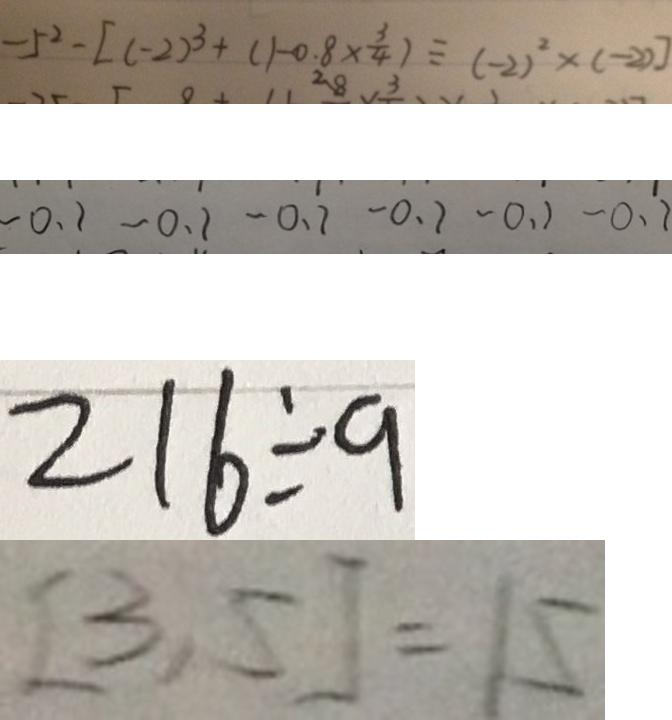<formula> <loc_0><loc_0><loc_500><loc_500>- 5 ^ { 2 } - [ ( - 2 ) ^ { 3 } + ( 1 + 0 . 8 \times \frac { 3 } { 4 } ) \div ( - 2 ) ^ { 2 } \times ( - 2 ) ] 
 - 0 . 1 - 0 . 1 - 0 . 1 - 0 . 1 - 0 . 1 - 0 . 1 
 2 1 6 \div a 
 [ 3 , 5 ] = 1 5</formula> 